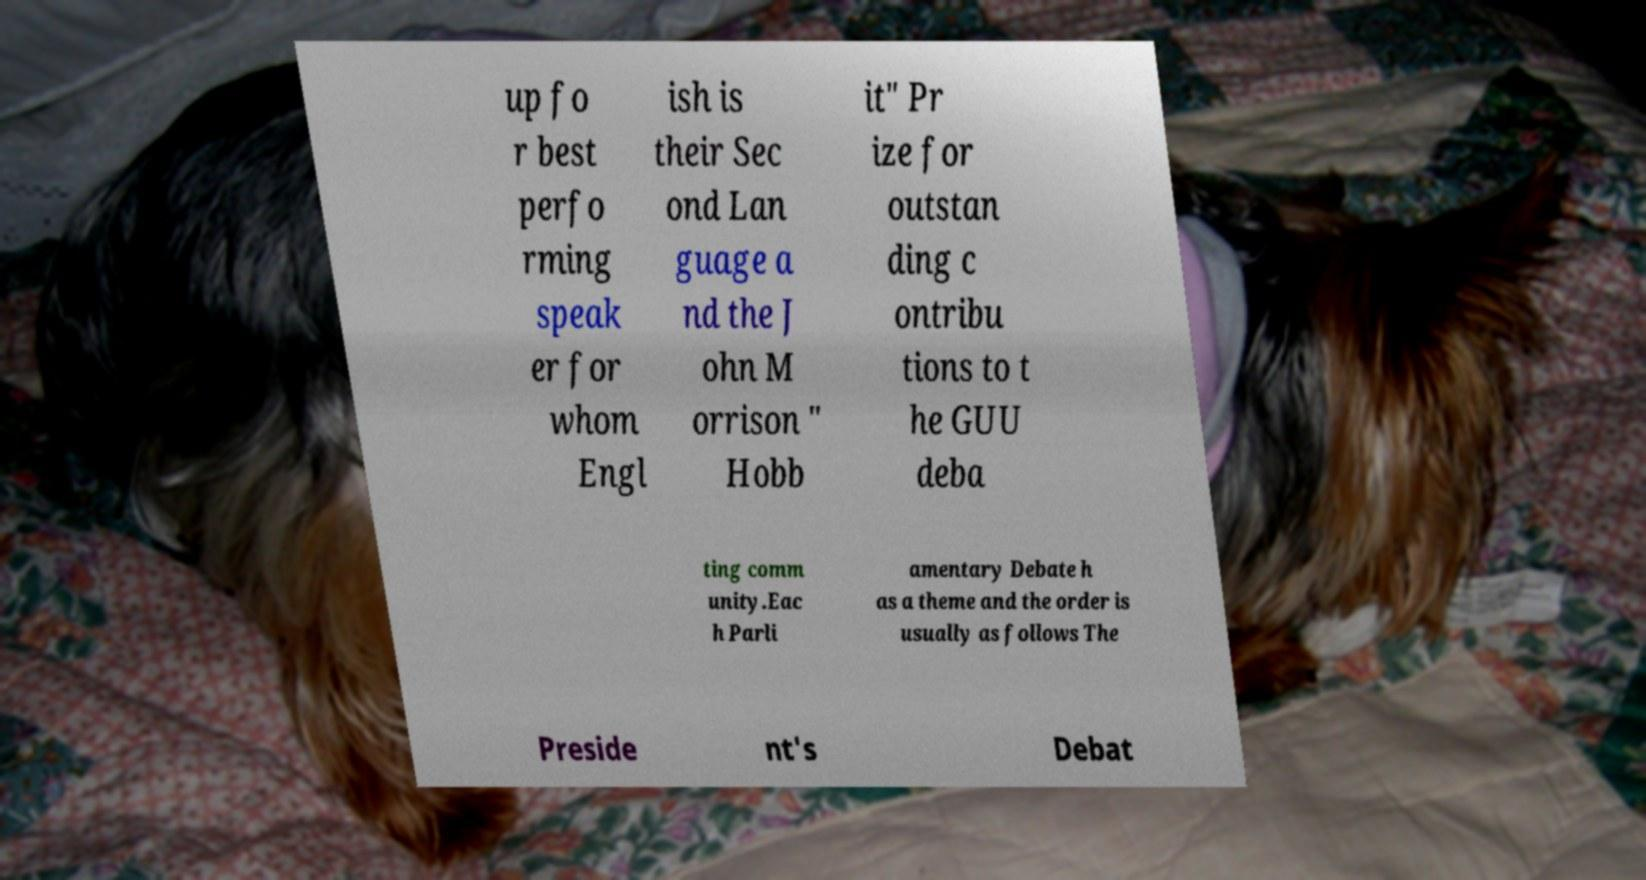For documentation purposes, I need the text within this image transcribed. Could you provide that? up fo r best perfo rming speak er for whom Engl ish is their Sec ond Lan guage a nd the J ohn M orrison " Hobb it" Pr ize for outstan ding c ontribu tions to t he GUU deba ting comm unity.Eac h Parli amentary Debate h as a theme and the order is usually as follows The Preside nt's Debat 